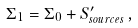<formula> <loc_0><loc_0><loc_500><loc_500>\Sigma _ { 1 } = \Sigma _ { 0 } + S _ { s o u r c e s } ^ { \prime } \, ,</formula> 